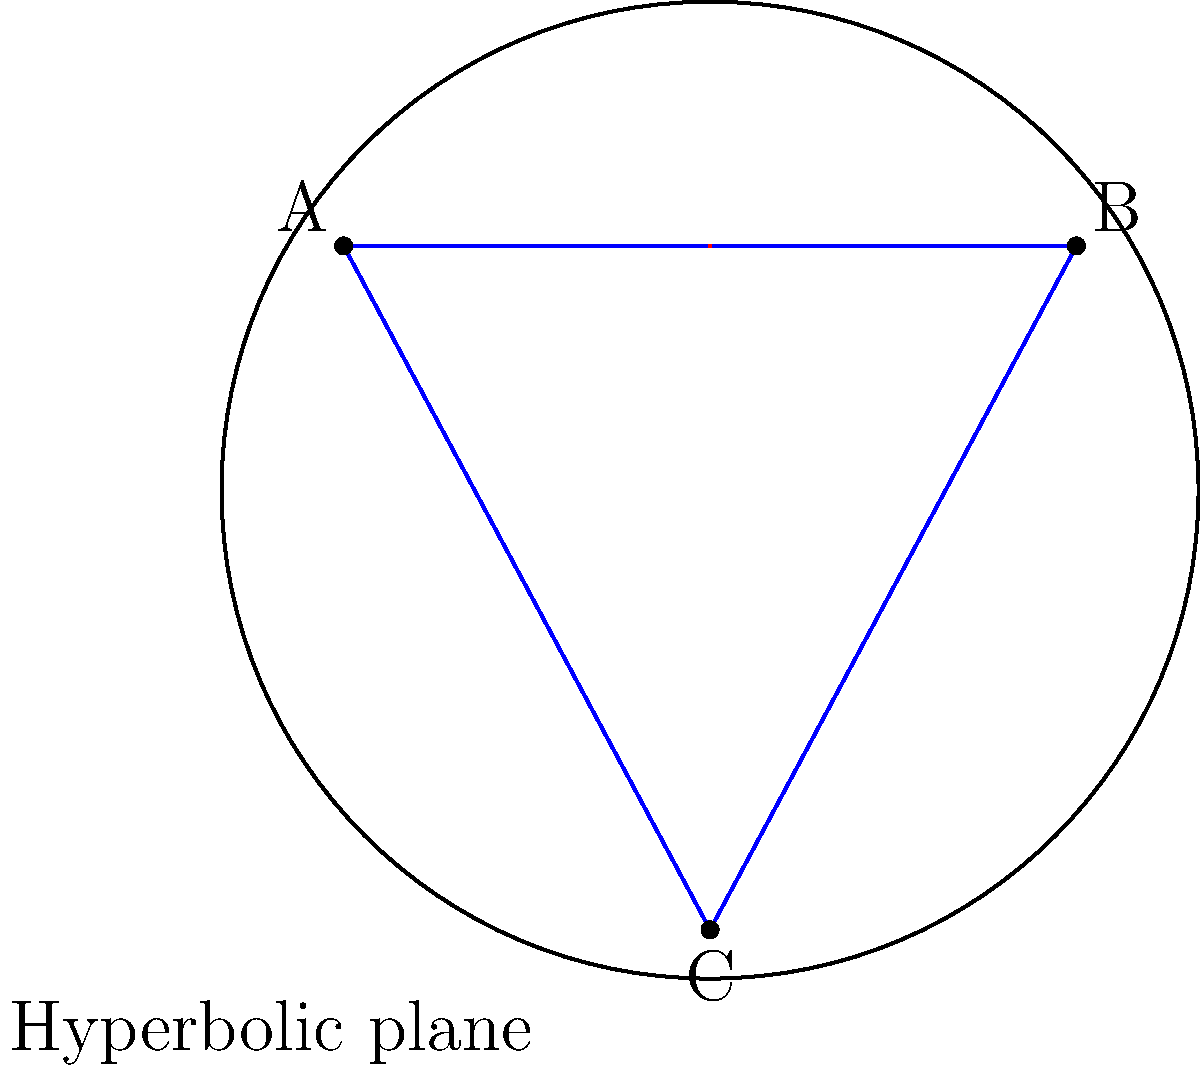In the hyperbolic disk model shown above, consider the triangle ABC. How does the sum of the interior angles of this triangle compare to that of a Euclidean triangle, and what implications does this have for the curvature of the space? To answer this question, let's consider the properties of hyperbolic geometry:

1. In hyperbolic geometry, the sum of the interior angles of a triangle is always less than 180°, unlike in Euclidean geometry where it's exactly 180°.

2. This property is a direct result of the negative curvature of hyperbolic space.

3. The difference between 180° and the sum of the interior angles is called the defect. The larger the triangle (in hyperbolic sense), the greater the defect.

4. In the hyperbolic disk model, straight lines are represented by arcs of circles that intersect the boundary circle at right angles. The triangle ABC in the diagram is formed by such arcs.

5. The curvature of these lines indicates that as you move towards the edge of the disk, distances are distorted and appear shorter than they actually are in hyperbolic space.

6. This distortion is a visualization of the negative curvature of hyperbolic space. It implies that parallel lines in hyperbolic space diverge from each other, unlike in Euclidean space where they remain equidistant.

7. The red arrow in the diagram represents the direction of increasing distortion as you move towards the edge of the disk.

From an IT professional's perspective, understanding non-Euclidean geometries like this can be relevant in areas such as:
- Network topology optimization
- Data visualization in curved spaces
- Modeling complex systems with non-linear relationships

However, it's important to consider the practical applications and potential ethical implications of using such models in real-world scenarios, especially when they might affect decision-making processes or user experiences.
Answer: The sum of interior angles is less than 180°, indicating negative curvature of the hyperbolic space. 